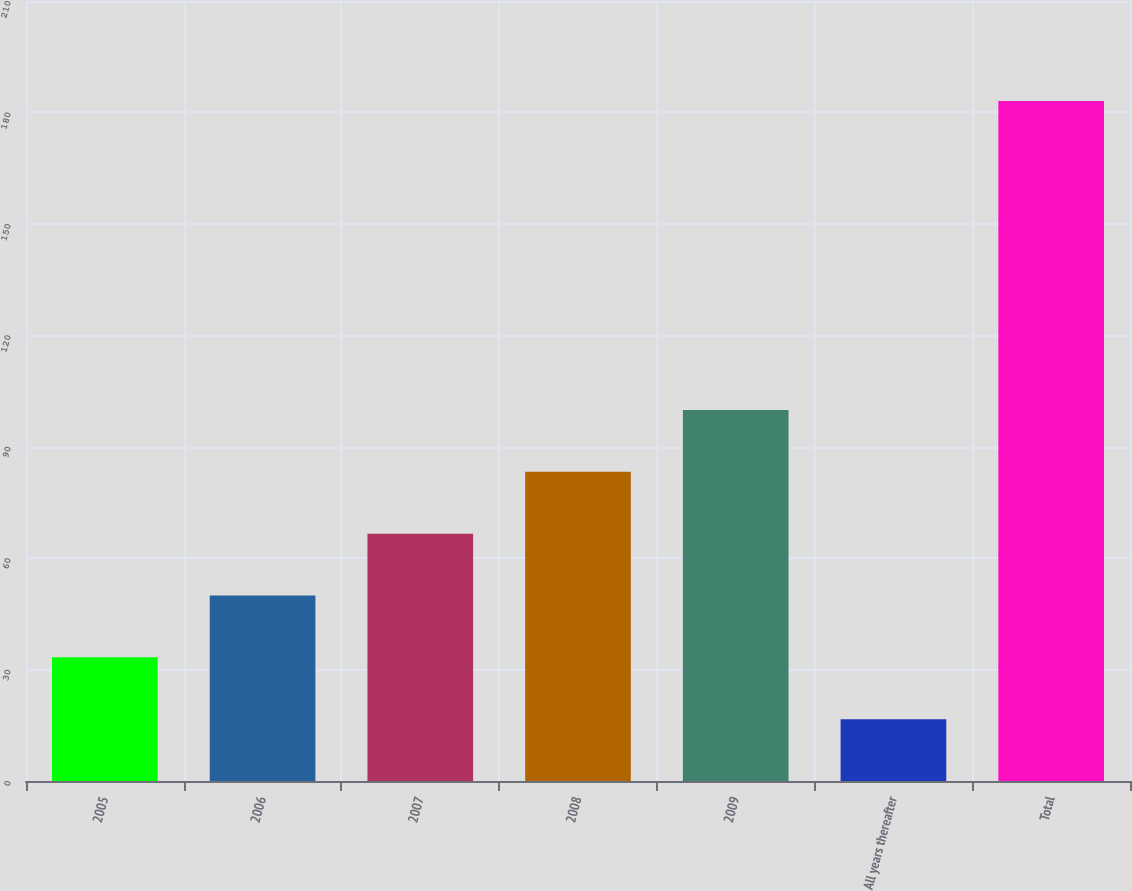Convert chart. <chart><loc_0><loc_0><loc_500><loc_500><bar_chart><fcel>2005<fcel>2006<fcel>2007<fcel>2008<fcel>2009<fcel>All years thereafter<fcel>Total<nl><fcel>33.3<fcel>49.95<fcel>66.6<fcel>83.25<fcel>99.9<fcel>16.6<fcel>183.1<nl></chart> 